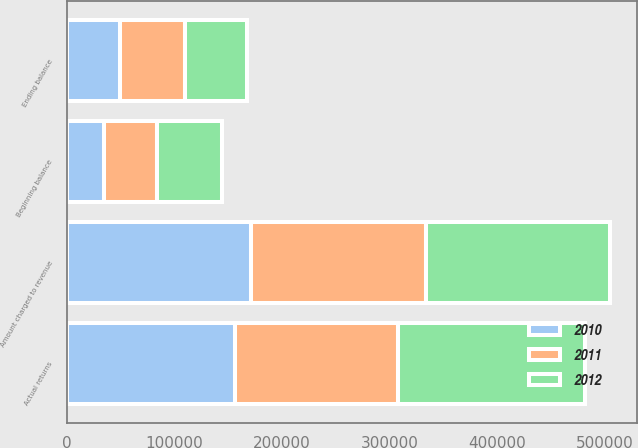Convert chart. <chart><loc_0><loc_0><loc_500><loc_500><stacked_bar_chart><ecel><fcel>Beginning balance<fcel>Amount charged to revenue<fcel>Actual returns<fcel>Ending balance<nl><fcel>2012<fcel>60887<fcel>170839<fcel>174668<fcel>57058<nl><fcel>2011<fcel>49426<fcel>162491<fcel>151030<fcel>60887<nl><fcel>2010<fcel>34401<fcel>171607<fcel>156582<fcel>49426<nl></chart> 